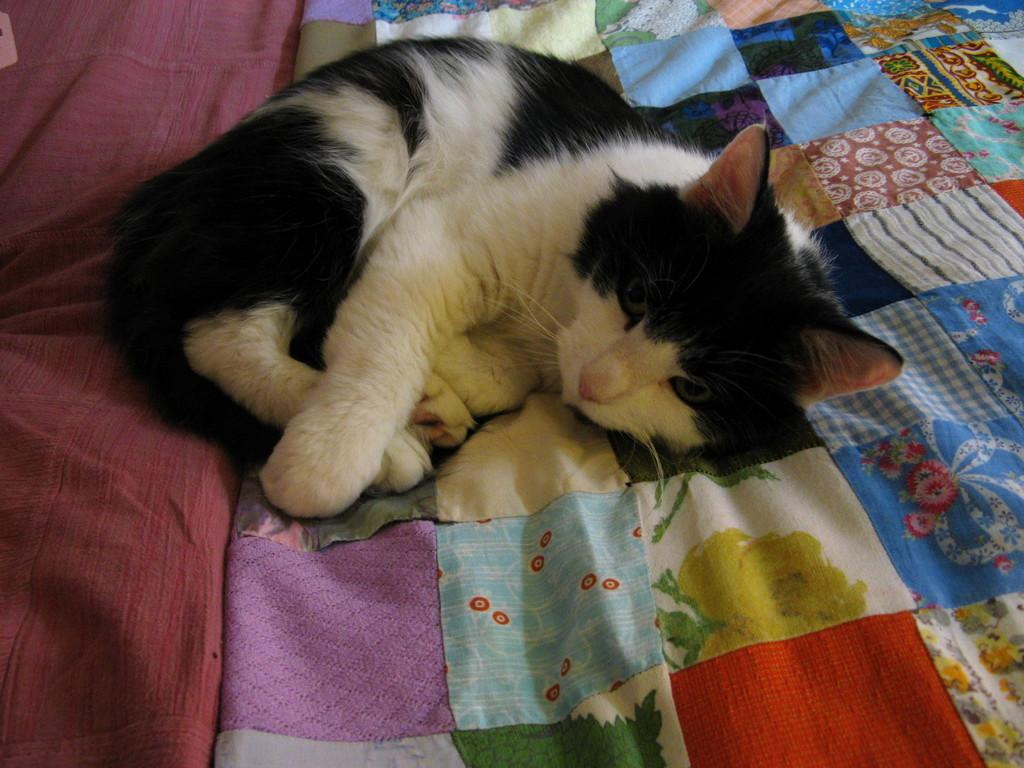What type of animal is in the image? There is a cat in the image. Where is the cat located? The cat is lying on a bed. What type of leaf is the cat holding in its paw in the image? There is no leaf present in the image, and the cat is not holding anything in its paw. 